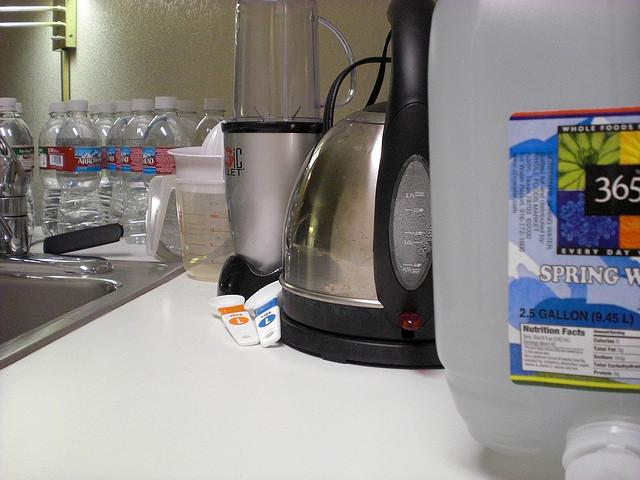What appliance is behind the coffee maker?
Give a very brief answer. Blender. Are the water bottles all the same size?
Keep it brief. Yes. Are the water bottles full?
Concise answer only. Yes. How many water bottles are there?
Be succinct. 10. 